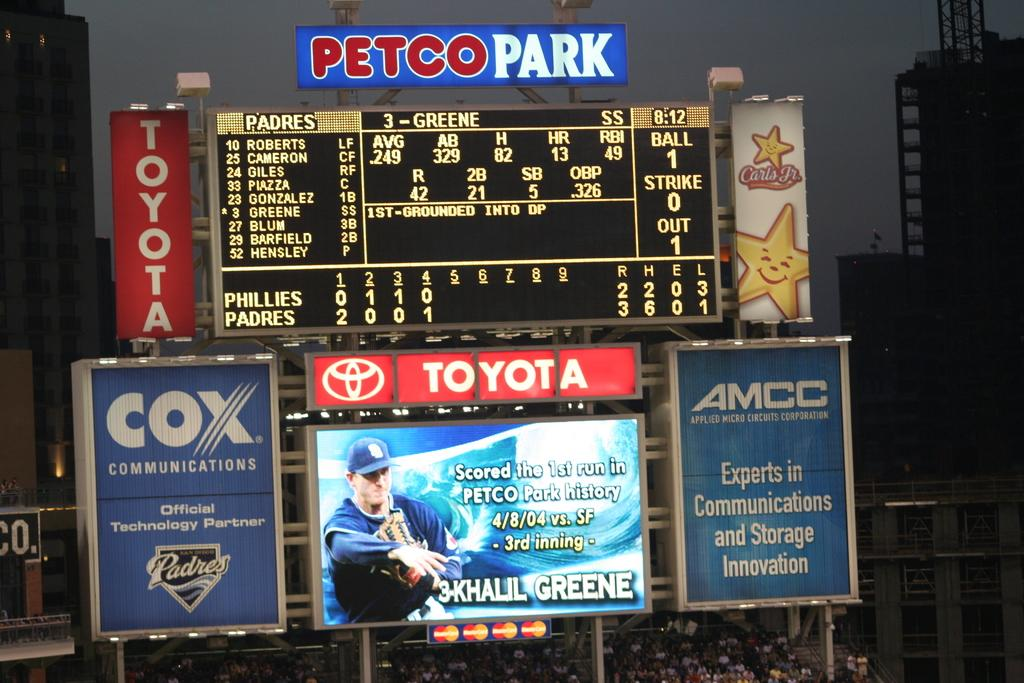Provide a one-sentence caption for the provided image. MLB scoreboard telling the amount of innings, the score and ball/strike/outs. 